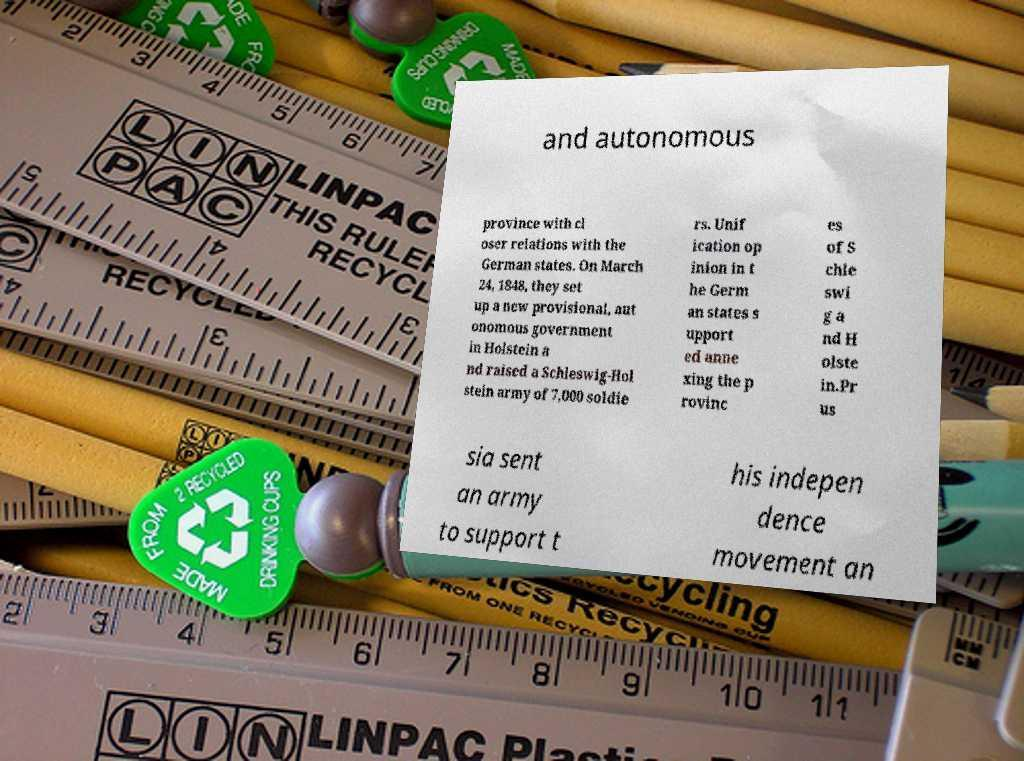Please read and relay the text visible in this image. What does it say? and autonomous province with cl oser relations with the German states. On March 24, 1848, they set up a new provisional, aut onomous government in Holstein a nd raised a Schleswig-Hol stein army of 7,000 soldie rs. Unif ication op inion in t he Germ an states s upport ed anne xing the p rovinc es of S chle swi g a nd H olste in.Pr us sia sent an army to support t his indepen dence movement an 